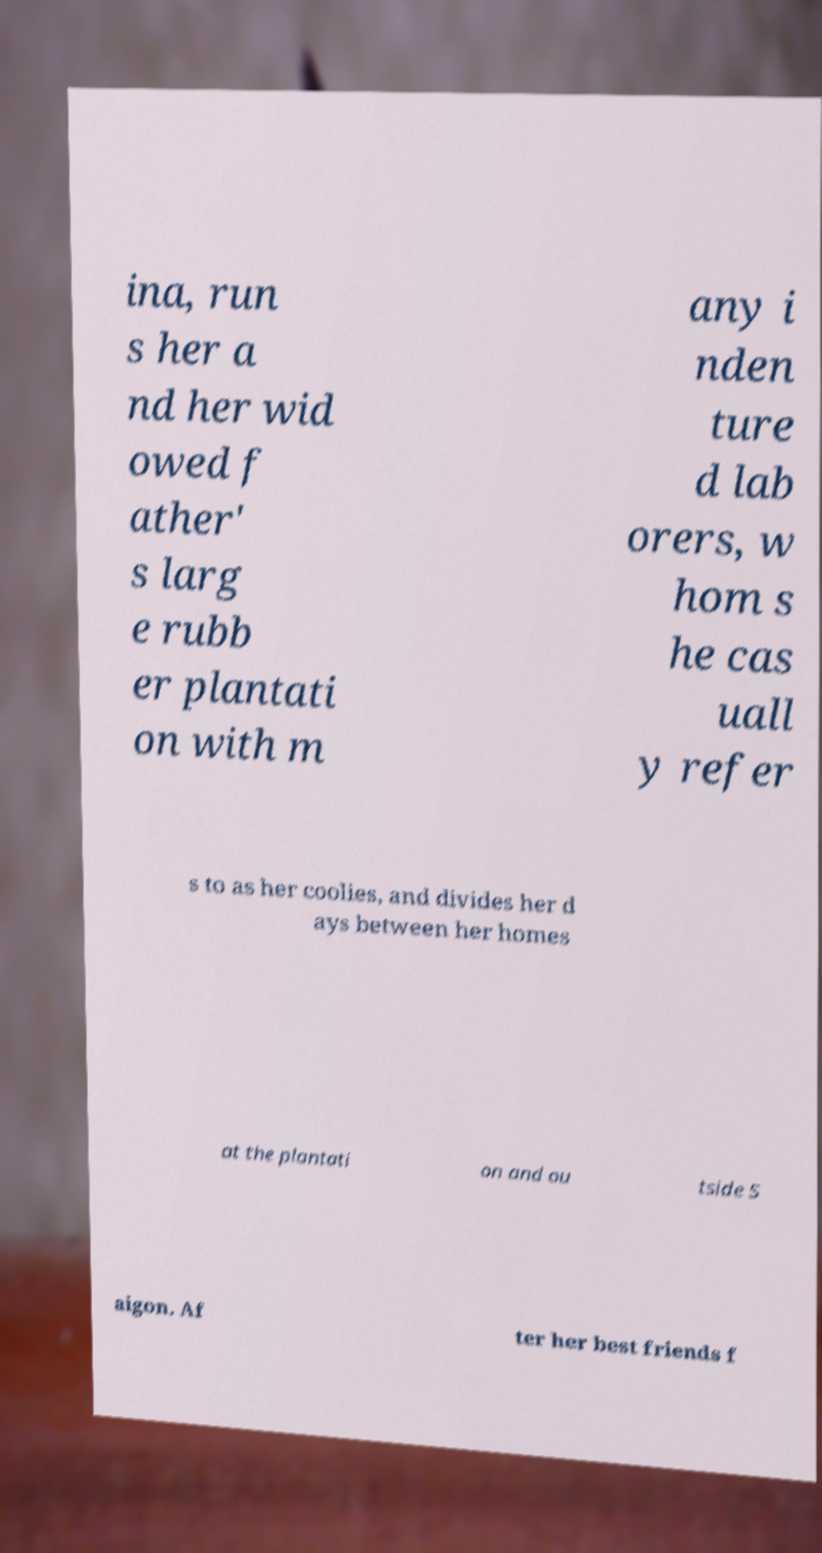Please read and relay the text visible in this image. What does it say? ina, run s her a nd her wid owed f ather' s larg e rubb er plantati on with m any i nden ture d lab orers, w hom s he cas uall y refer s to as her coolies, and divides her d ays between her homes at the plantati on and ou tside S aigon. Af ter her best friends f 